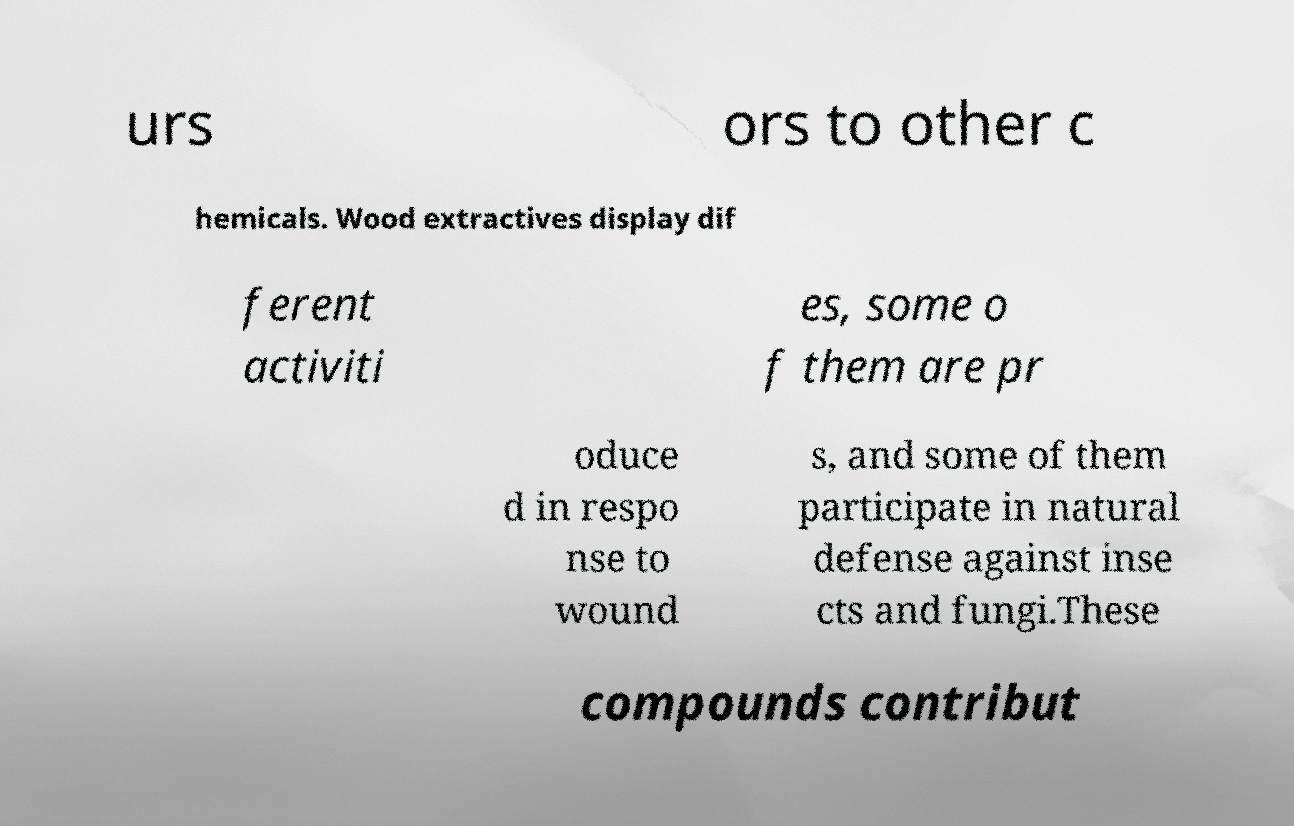Can you read and provide the text displayed in the image?This photo seems to have some interesting text. Can you extract and type it out for me? urs ors to other c hemicals. Wood extractives display dif ferent activiti es, some o f them are pr oduce d in respo nse to wound s, and some of them participate in natural defense against inse cts and fungi.These compounds contribut 